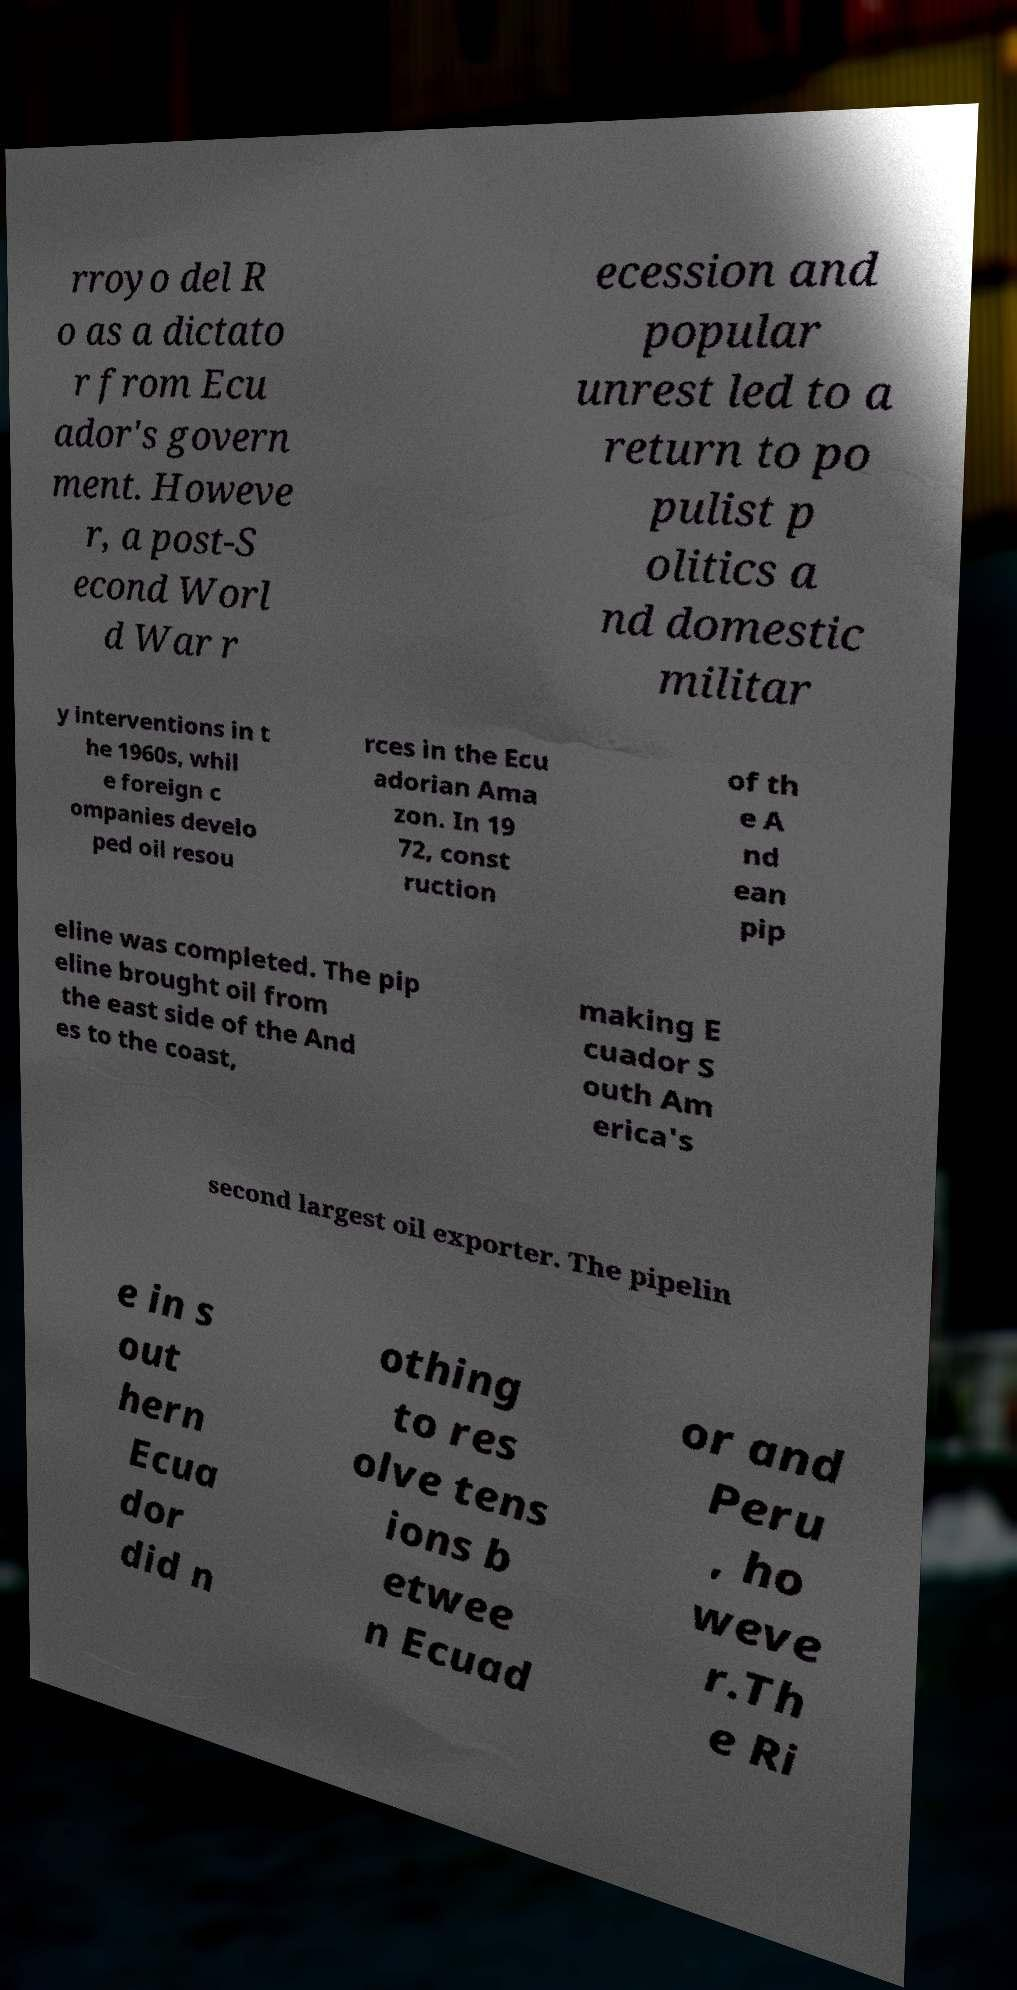Could you assist in decoding the text presented in this image and type it out clearly? rroyo del R o as a dictato r from Ecu ador's govern ment. Howeve r, a post-S econd Worl d War r ecession and popular unrest led to a return to po pulist p olitics a nd domestic militar y interventions in t he 1960s, whil e foreign c ompanies develo ped oil resou rces in the Ecu adorian Ama zon. In 19 72, const ruction of th e A nd ean pip eline was completed. The pip eline brought oil from the east side of the And es to the coast, making E cuador S outh Am erica's second largest oil exporter. The pipelin e in s out hern Ecua dor did n othing to res olve tens ions b etwee n Ecuad or and Peru , ho weve r.Th e Ri 